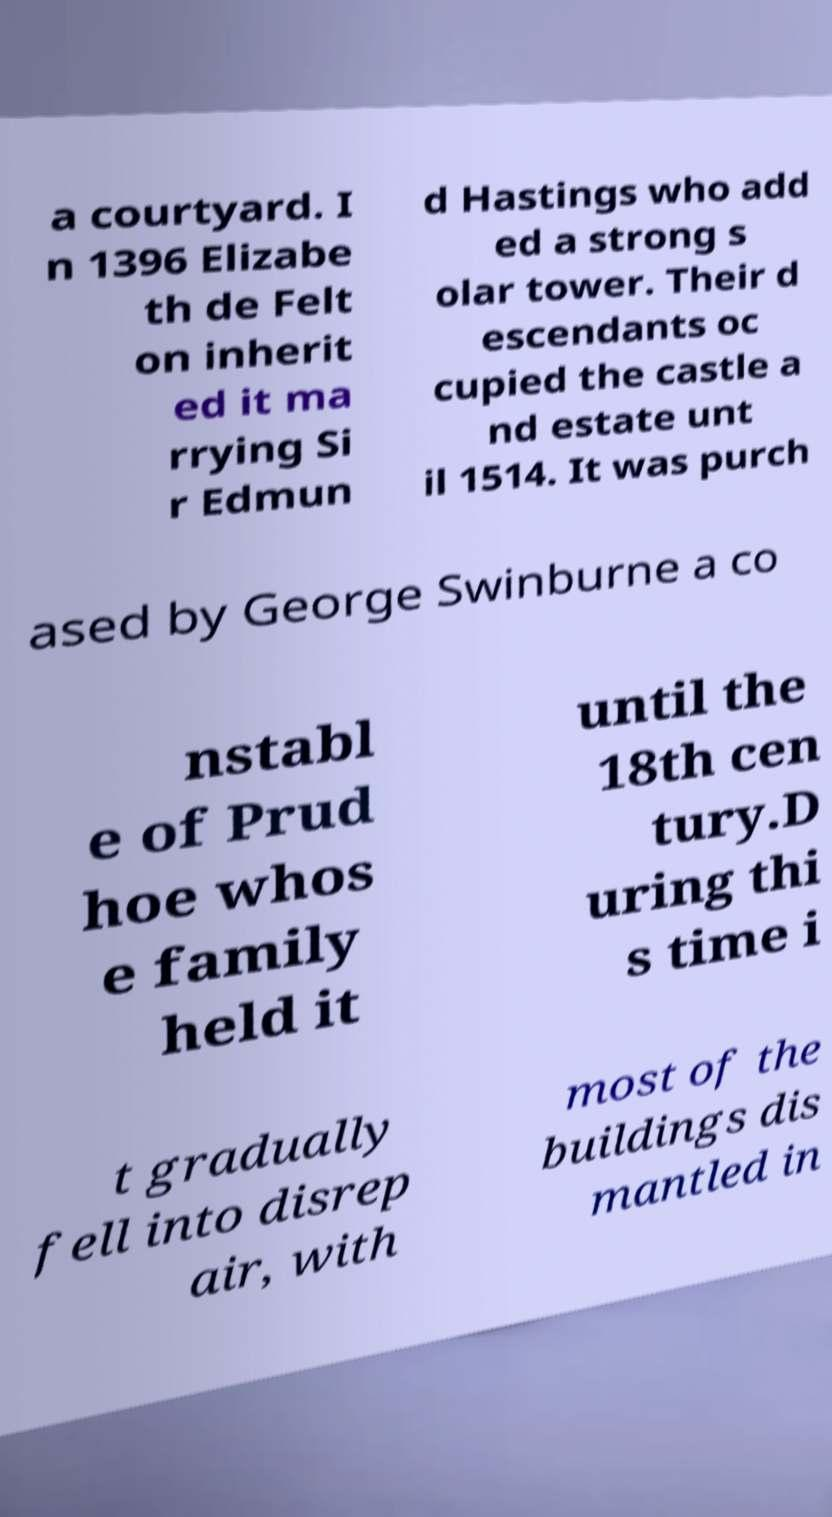Can you accurately transcribe the text from the provided image for me? a courtyard. I n 1396 Elizabe th de Felt on inherit ed it ma rrying Si r Edmun d Hastings who add ed a strong s olar tower. Their d escendants oc cupied the castle a nd estate unt il 1514. It was purch ased by George Swinburne a co nstabl e of Prud hoe whos e family held it until the 18th cen tury.D uring thi s time i t gradually fell into disrep air, with most of the buildings dis mantled in 